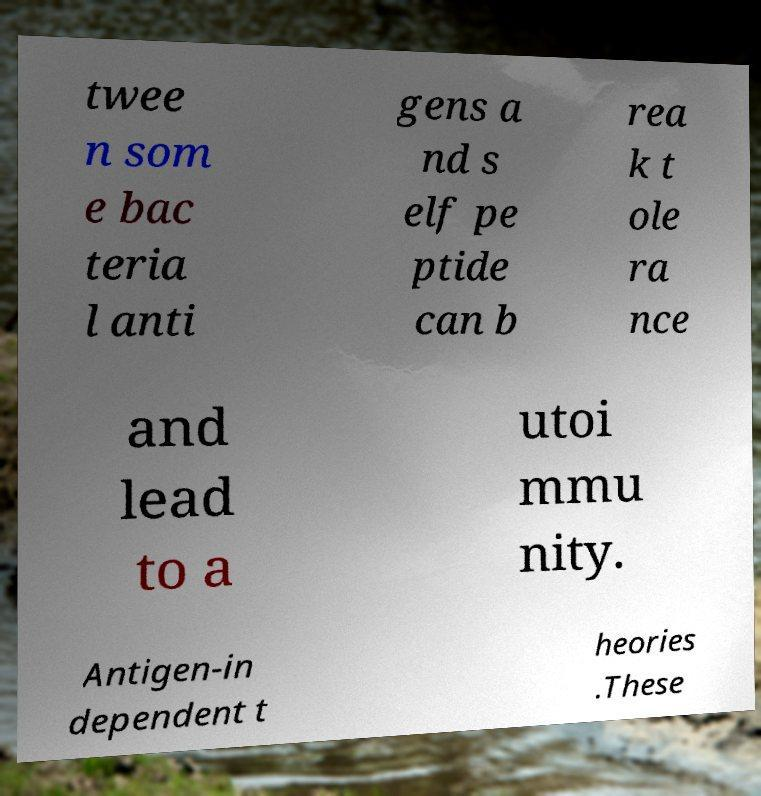Please identify and transcribe the text found in this image. twee n som e bac teria l anti gens a nd s elf pe ptide can b rea k t ole ra nce and lead to a utoi mmu nity. Antigen-in dependent t heories .These 